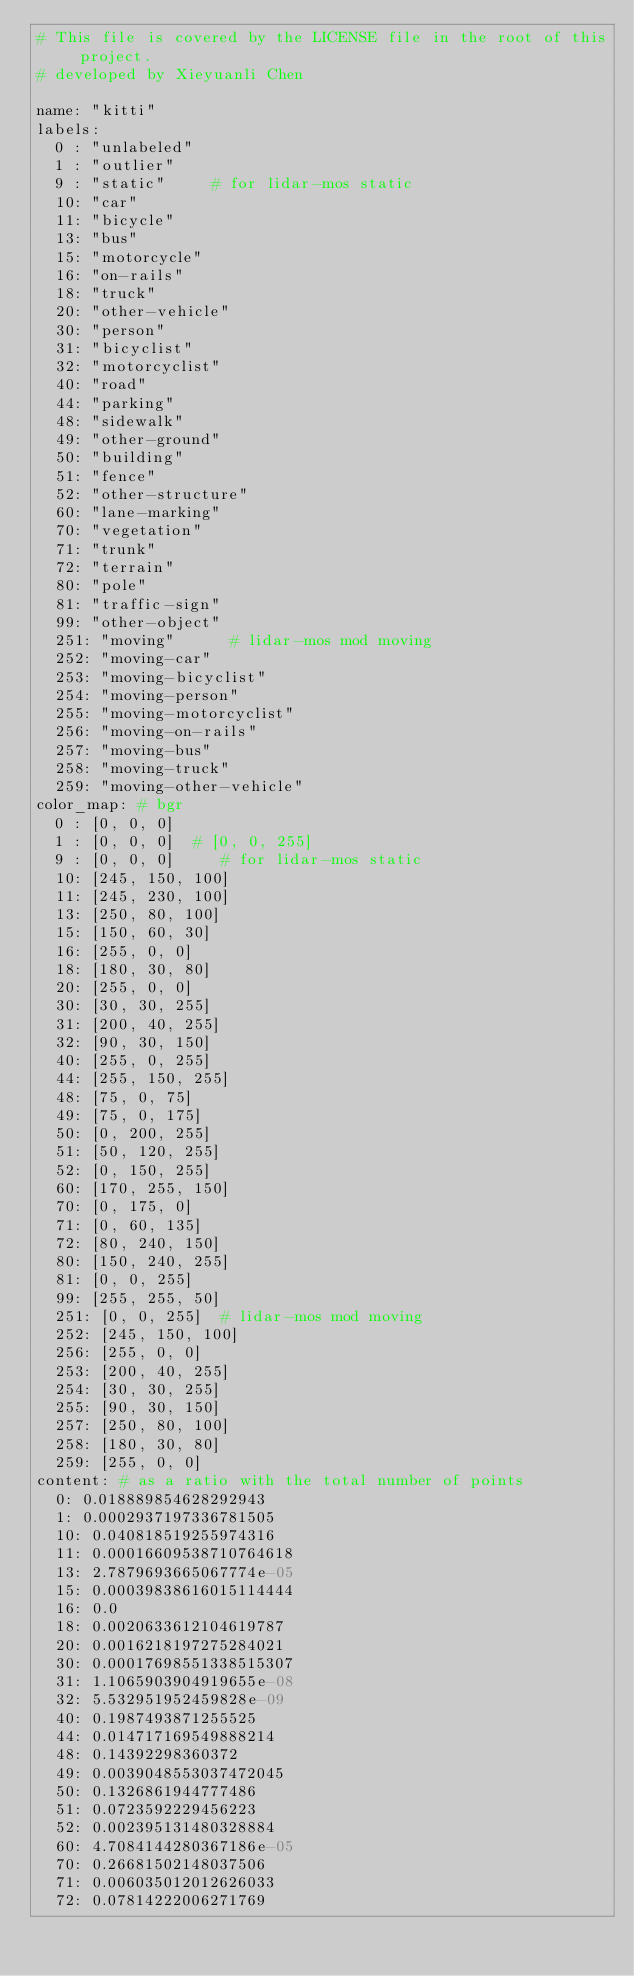Convert code to text. <code><loc_0><loc_0><loc_500><loc_500><_YAML_># This file is covered by the LICENSE file in the root of this project.
# developed by Xieyuanli Chen

name: "kitti"
labels: 
  0 : "unlabeled"
  1 : "outlier"
  9 : "static"     # for lidar-mos static 
  10: "car"
  11: "bicycle"
  13: "bus"
  15: "motorcycle"
  16: "on-rails"
  18: "truck"
  20: "other-vehicle"
  30: "person"
  31: "bicyclist"
  32: "motorcyclist"
  40: "road"
  44: "parking"
  48: "sidewalk"
  49: "other-ground"
  50: "building"
  51: "fence"
  52: "other-structure"
  60: "lane-marking"
  70: "vegetation"
  71: "trunk"
  72: "terrain"
  80: "pole"
  81: "traffic-sign"
  99: "other-object"
  251: "moving"      # lidar-mos mod moving
  252: "moving-car"
  253: "moving-bicyclist"
  254: "moving-person"
  255: "moving-motorcyclist"
  256: "moving-on-rails"
  257: "moving-bus"
  258: "moving-truck"
  259: "moving-other-vehicle"
color_map: # bgr
  0 : [0, 0, 0]
  1 : [0, 0, 0]  # [0, 0, 255] 
  9 : [0, 0, 0]     # for lidar-mos static
  10: [245, 150, 100]
  11: [245, 230, 100]
  13: [250, 80, 100]
  15: [150, 60, 30]
  16: [255, 0, 0]
  18: [180, 30, 80]
  20: [255, 0, 0]
  30: [30, 30, 255]
  31: [200, 40, 255]
  32: [90, 30, 150]
  40: [255, 0, 255]
  44: [255, 150, 255]
  48: [75, 0, 75]
  49: [75, 0, 175]
  50: [0, 200, 255]
  51: [50, 120, 255]
  52: [0, 150, 255]
  60: [170, 255, 150]
  70: [0, 175, 0]
  71: [0, 60, 135]
  72: [80, 240, 150]
  80: [150, 240, 255]
  81: [0, 0, 255]
  99: [255, 255, 50]
  251: [0, 0, 255]  # lidar-mos mod moving
  252: [245, 150, 100]
  256: [255, 0, 0]
  253: [200, 40, 255]
  254: [30, 30, 255]
  255: [90, 30, 150]
  257: [250, 80, 100]
  258: [180, 30, 80]
  259: [255, 0, 0]
content: # as a ratio with the total number of points
  0: 0.018889854628292943
  1: 0.0002937197336781505
  10: 0.040818519255974316
  11: 0.00016609538710764618
  13: 2.7879693665067774e-05
  15: 0.00039838616015114444
  16: 0.0
  18: 0.0020633612104619787
  20: 0.0016218197275284021
  30: 0.00017698551338515307
  31: 1.1065903904919655e-08
  32: 5.532951952459828e-09
  40: 0.1987493871255525
  44: 0.014717169549888214
  48: 0.14392298360372
  49: 0.0039048553037472045
  50: 0.1326861944777486
  51: 0.0723592229456223
  52: 0.002395131480328884
  60: 4.7084144280367186e-05
  70: 0.26681502148037506
  71: 0.006035012012626033
  72: 0.07814222006271769</code> 